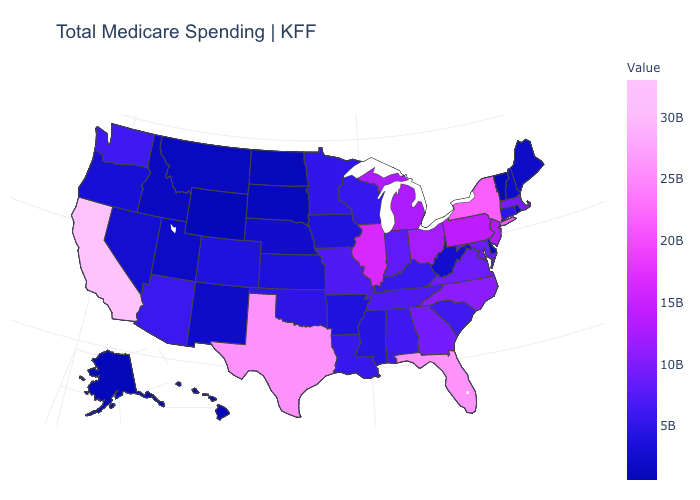Among the states that border New Hampshire , which have the highest value?
Concise answer only. Massachusetts. Which states have the highest value in the USA?
Answer briefly. California. Which states hav the highest value in the Northeast?
Quick response, please. New York. Does New York have the highest value in the Northeast?
Quick response, please. Yes. Which states hav the highest value in the Northeast?
Answer briefly. New York. Does Pennsylvania have a lower value than Maine?
Concise answer only. No. 